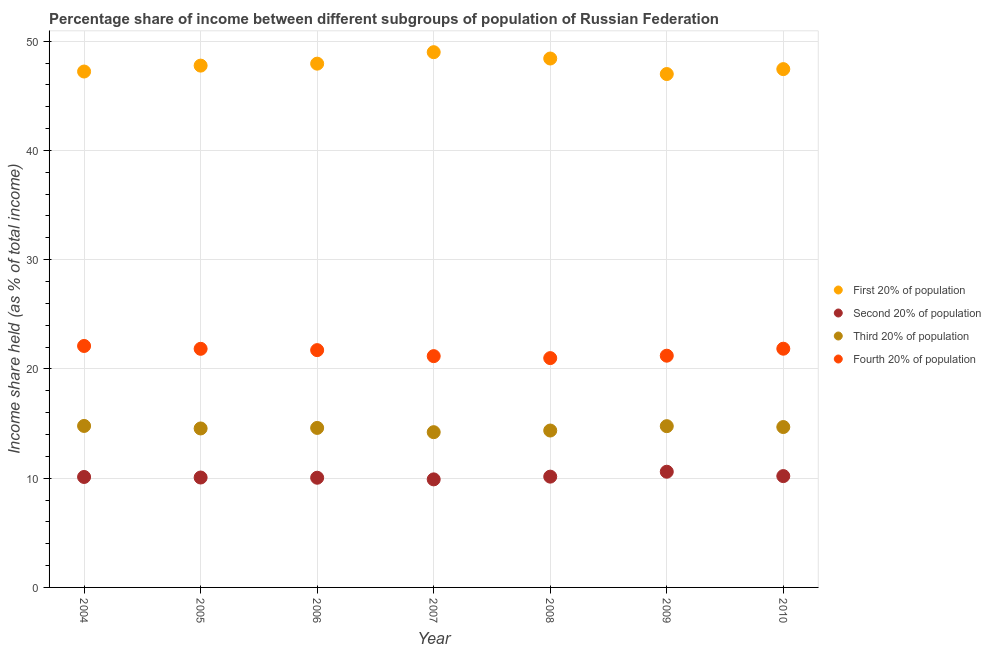How many different coloured dotlines are there?
Offer a terse response. 4. Is the number of dotlines equal to the number of legend labels?
Give a very brief answer. Yes. What is the share of the income held by second 20% of the population in 2006?
Keep it short and to the point. 10.04. Across all years, what is the maximum share of the income held by fourth 20% of the population?
Your answer should be compact. 22.1. Across all years, what is the minimum share of the income held by third 20% of the population?
Your answer should be compact. 14.21. In which year was the share of the income held by first 20% of the population minimum?
Provide a short and direct response. 2009. What is the total share of the income held by second 20% of the population in the graph?
Make the answer very short. 71.02. What is the difference between the share of the income held by first 20% of the population in 2005 and that in 2010?
Your answer should be very brief. 0.32. What is the difference between the share of the income held by fourth 20% of the population in 2006 and the share of the income held by second 20% of the population in 2009?
Provide a succinct answer. 11.13. What is the average share of the income held by third 20% of the population per year?
Give a very brief answer. 14.56. In the year 2006, what is the difference between the share of the income held by first 20% of the population and share of the income held by third 20% of the population?
Make the answer very short. 33.34. In how many years, is the share of the income held by second 20% of the population greater than 6 %?
Provide a succinct answer. 7. What is the ratio of the share of the income held by first 20% of the population in 2005 to that in 2010?
Provide a succinct answer. 1.01. What is the difference between the highest and the second highest share of the income held by third 20% of the population?
Provide a succinct answer. 0.02. What is the difference between the highest and the lowest share of the income held by fourth 20% of the population?
Keep it short and to the point. 1.11. Is the sum of the share of the income held by third 20% of the population in 2005 and 2009 greater than the maximum share of the income held by first 20% of the population across all years?
Offer a terse response. No. Is it the case that in every year, the sum of the share of the income held by second 20% of the population and share of the income held by first 20% of the population is greater than the sum of share of the income held by third 20% of the population and share of the income held by fourth 20% of the population?
Your answer should be compact. Yes. Does the share of the income held by second 20% of the population monotonically increase over the years?
Provide a short and direct response. No. Is the share of the income held by first 20% of the population strictly greater than the share of the income held by fourth 20% of the population over the years?
Your response must be concise. Yes. Is the share of the income held by third 20% of the population strictly less than the share of the income held by fourth 20% of the population over the years?
Offer a terse response. Yes. How many years are there in the graph?
Offer a very short reply. 7. Are the values on the major ticks of Y-axis written in scientific E-notation?
Make the answer very short. No. Does the graph contain grids?
Make the answer very short. Yes. How many legend labels are there?
Your answer should be very brief. 4. What is the title of the graph?
Your answer should be compact. Percentage share of income between different subgroups of population of Russian Federation. What is the label or title of the X-axis?
Ensure brevity in your answer.  Year. What is the label or title of the Y-axis?
Make the answer very short. Income share held (as % of total income). What is the Income share held (as % of total income) of First 20% of population in 2004?
Give a very brief answer. 47.22. What is the Income share held (as % of total income) in Second 20% of population in 2004?
Provide a succinct answer. 10.11. What is the Income share held (as % of total income) of Third 20% of population in 2004?
Keep it short and to the point. 14.78. What is the Income share held (as % of total income) in Fourth 20% of population in 2004?
Your response must be concise. 22.1. What is the Income share held (as % of total income) in First 20% of population in 2005?
Your answer should be very brief. 47.76. What is the Income share held (as % of total income) of Second 20% of population in 2005?
Offer a terse response. 10.06. What is the Income share held (as % of total income) in Third 20% of population in 2005?
Provide a succinct answer. 14.55. What is the Income share held (as % of total income) of Fourth 20% of population in 2005?
Make the answer very short. 21.84. What is the Income share held (as % of total income) in First 20% of population in 2006?
Provide a short and direct response. 47.94. What is the Income share held (as % of total income) of Second 20% of population in 2006?
Give a very brief answer. 10.04. What is the Income share held (as % of total income) in Fourth 20% of population in 2006?
Provide a short and direct response. 21.72. What is the Income share held (as % of total income) of First 20% of population in 2007?
Provide a succinct answer. 48.99. What is the Income share held (as % of total income) of Second 20% of population in 2007?
Offer a terse response. 9.89. What is the Income share held (as % of total income) in Third 20% of population in 2007?
Give a very brief answer. 14.21. What is the Income share held (as % of total income) in Fourth 20% of population in 2007?
Offer a terse response. 21.17. What is the Income share held (as % of total income) in First 20% of population in 2008?
Give a very brief answer. 48.41. What is the Income share held (as % of total income) of Second 20% of population in 2008?
Make the answer very short. 10.14. What is the Income share held (as % of total income) in Third 20% of population in 2008?
Ensure brevity in your answer.  14.36. What is the Income share held (as % of total income) in Fourth 20% of population in 2008?
Your answer should be very brief. 20.99. What is the Income share held (as % of total income) of First 20% of population in 2009?
Ensure brevity in your answer.  46.99. What is the Income share held (as % of total income) of Second 20% of population in 2009?
Make the answer very short. 10.59. What is the Income share held (as % of total income) in Third 20% of population in 2009?
Your response must be concise. 14.76. What is the Income share held (as % of total income) of Fourth 20% of population in 2009?
Your answer should be compact. 21.21. What is the Income share held (as % of total income) in First 20% of population in 2010?
Ensure brevity in your answer.  47.44. What is the Income share held (as % of total income) of Second 20% of population in 2010?
Your answer should be very brief. 10.19. What is the Income share held (as % of total income) of Third 20% of population in 2010?
Make the answer very short. 14.68. What is the Income share held (as % of total income) of Fourth 20% of population in 2010?
Give a very brief answer. 21.85. Across all years, what is the maximum Income share held (as % of total income) of First 20% of population?
Ensure brevity in your answer.  48.99. Across all years, what is the maximum Income share held (as % of total income) in Second 20% of population?
Make the answer very short. 10.59. Across all years, what is the maximum Income share held (as % of total income) of Third 20% of population?
Your answer should be compact. 14.78. Across all years, what is the maximum Income share held (as % of total income) of Fourth 20% of population?
Provide a short and direct response. 22.1. Across all years, what is the minimum Income share held (as % of total income) in First 20% of population?
Make the answer very short. 46.99. Across all years, what is the minimum Income share held (as % of total income) of Second 20% of population?
Your response must be concise. 9.89. Across all years, what is the minimum Income share held (as % of total income) in Third 20% of population?
Ensure brevity in your answer.  14.21. Across all years, what is the minimum Income share held (as % of total income) of Fourth 20% of population?
Keep it short and to the point. 20.99. What is the total Income share held (as % of total income) in First 20% of population in the graph?
Your answer should be very brief. 334.75. What is the total Income share held (as % of total income) in Second 20% of population in the graph?
Make the answer very short. 71.02. What is the total Income share held (as % of total income) of Third 20% of population in the graph?
Provide a short and direct response. 101.94. What is the total Income share held (as % of total income) of Fourth 20% of population in the graph?
Ensure brevity in your answer.  150.88. What is the difference between the Income share held (as % of total income) of First 20% of population in 2004 and that in 2005?
Your answer should be very brief. -0.54. What is the difference between the Income share held (as % of total income) of Third 20% of population in 2004 and that in 2005?
Offer a very short reply. 0.23. What is the difference between the Income share held (as % of total income) in Fourth 20% of population in 2004 and that in 2005?
Your answer should be compact. 0.26. What is the difference between the Income share held (as % of total income) of First 20% of population in 2004 and that in 2006?
Your answer should be compact. -0.72. What is the difference between the Income share held (as % of total income) in Second 20% of population in 2004 and that in 2006?
Your answer should be compact. 0.07. What is the difference between the Income share held (as % of total income) of Third 20% of population in 2004 and that in 2006?
Make the answer very short. 0.18. What is the difference between the Income share held (as % of total income) in Fourth 20% of population in 2004 and that in 2006?
Provide a succinct answer. 0.38. What is the difference between the Income share held (as % of total income) in First 20% of population in 2004 and that in 2007?
Offer a terse response. -1.77. What is the difference between the Income share held (as % of total income) in Second 20% of population in 2004 and that in 2007?
Offer a very short reply. 0.22. What is the difference between the Income share held (as % of total income) of Third 20% of population in 2004 and that in 2007?
Your answer should be very brief. 0.57. What is the difference between the Income share held (as % of total income) of Fourth 20% of population in 2004 and that in 2007?
Make the answer very short. 0.93. What is the difference between the Income share held (as % of total income) in First 20% of population in 2004 and that in 2008?
Provide a short and direct response. -1.19. What is the difference between the Income share held (as % of total income) in Second 20% of population in 2004 and that in 2008?
Provide a short and direct response. -0.03. What is the difference between the Income share held (as % of total income) in Third 20% of population in 2004 and that in 2008?
Provide a succinct answer. 0.42. What is the difference between the Income share held (as % of total income) in Fourth 20% of population in 2004 and that in 2008?
Make the answer very short. 1.11. What is the difference between the Income share held (as % of total income) in First 20% of population in 2004 and that in 2009?
Your answer should be very brief. 0.23. What is the difference between the Income share held (as % of total income) of Second 20% of population in 2004 and that in 2009?
Your answer should be compact. -0.48. What is the difference between the Income share held (as % of total income) of Third 20% of population in 2004 and that in 2009?
Keep it short and to the point. 0.02. What is the difference between the Income share held (as % of total income) of Fourth 20% of population in 2004 and that in 2009?
Your response must be concise. 0.89. What is the difference between the Income share held (as % of total income) of First 20% of population in 2004 and that in 2010?
Provide a succinct answer. -0.22. What is the difference between the Income share held (as % of total income) in Second 20% of population in 2004 and that in 2010?
Your answer should be very brief. -0.08. What is the difference between the Income share held (as % of total income) in Fourth 20% of population in 2004 and that in 2010?
Keep it short and to the point. 0.25. What is the difference between the Income share held (as % of total income) of First 20% of population in 2005 and that in 2006?
Provide a short and direct response. -0.18. What is the difference between the Income share held (as % of total income) of Second 20% of population in 2005 and that in 2006?
Your response must be concise. 0.02. What is the difference between the Income share held (as % of total income) of Fourth 20% of population in 2005 and that in 2006?
Your response must be concise. 0.12. What is the difference between the Income share held (as % of total income) of First 20% of population in 2005 and that in 2007?
Your answer should be very brief. -1.23. What is the difference between the Income share held (as % of total income) of Second 20% of population in 2005 and that in 2007?
Provide a short and direct response. 0.17. What is the difference between the Income share held (as % of total income) of Third 20% of population in 2005 and that in 2007?
Offer a very short reply. 0.34. What is the difference between the Income share held (as % of total income) of Fourth 20% of population in 2005 and that in 2007?
Your answer should be compact. 0.67. What is the difference between the Income share held (as % of total income) of First 20% of population in 2005 and that in 2008?
Offer a very short reply. -0.65. What is the difference between the Income share held (as % of total income) in Second 20% of population in 2005 and that in 2008?
Provide a succinct answer. -0.08. What is the difference between the Income share held (as % of total income) of Third 20% of population in 2005 and that in 2008?
Offer a very short reply. 0.19. What is the difference between the Income share held (as % of total income) of First 20% of population in 2005 and that in 2009?
Provide a short and direct response. 0.77. What is the difference between the Income share held (as % of total income) in Second 20% of population in 2005 and that in 2009?
Your answer should be compact. -0.53. What is the difference between the Income share held (as % of total income) of Third 20% of population in 2005 and that in 2009?
Keep it short and to the point. -0.21. What is the difference between the Income share held (as % of total income) of Fourth 20% of population in 2005 and that in 2009?
Keep it short and to the point. 0.63. What is the difference between the Income share held (as % of total income) of First 20% of population in 2005 and that in 2010?
Offer a terse response. 0.32. What is the difference between the Income share held (as % of total income) of Second 20% of population in 2005 and that in 2010?
Your answer should be very brief. -0.13. What is the difference between the Income share held (as % of total income) in Third 20% of population in 2005 and that in 2010?
Your answer should be compact. -0.13. What is the difference between the Income share held (as % of total income) of Fourth 20% of population in 2005 and that in 2010?
Keep it short and to the point. -0.01. What is the difference between the Income share held (as % of total income) in First 20% of population in 2006 and that in 2007?
Offer a very short reply. -1.05. What is the difference between the Income share held (as % of total income) of Third 20% of population in 2006 and that in 2007?
Make the answer very short. 0.39. What is the difference between the Income share held (as % of total income) in Fourth 20% of population in 2006 and that in 2007?
Provide a succinct answer. 0.55. What is the difference between the Income share held (as % of total income) of First 20% of population in 2006 and that in 2008?
Offer a very short reply. -0.47. What is the difference between the Income share held (as % of total income) in Second 20% of population in 2006 and that in 2008?
Your answer should be compact. -0.1. What is the difference between the Income share held (as % of total income) of Third 20% of population in 2006 and that in 2008?
Your answer should be very brief. 0.24. What is the difference between the Income share held (as % of total income) of Fourth 20% of population in 2006 and that in 2008?
Ensure brevity in your answer.  0.73. What is the difference between the Income share held (as % of total income) in Second 20% of population in 2006 and that in 2009?
Your answer should be compact. -0.55. What is the difference between the Income share held (as % of total income) in Third 20% of population in 2006 and that in 2009?
Keep it short and to the point. -0.16. What is the difference between the Income share held (as % of total income) in Fourth 20% of population in 2006 and that in 2009?
Provide a short and direct response. 0.51. What is the difference between the Income share held (as % of total income) of First 20% of population in 2006 and that in 2010?
Your answer should be very brief. 0.5. What is the difference between the Income share held (as % of total income) of Second 20% of population in 2006 and that in 2010?
Give a very brief answer. -0.15. What is the difference between the Income share held (as % of total income) in Third 20% of population in 2006 and that in 2010?
Offer a terse response. -0.08. What is the difference between the Income share held (as % of total income) of Fourth 20% of population in 2006 and that in 2010?
Provide a short and direct response. -0.13. What is the difference between the Income share held (as % of total income) in First 20% of population in 2007 and that in 2008?
Provide a short and direct response. 0.58. What is the difference between the Income share held (as % of total income) of Third 20% of population in 2007 and that in 2008?
Give a very brief answer. -0.15. What is the difference between the Income share held (as % of total income) of Fourth 20% of population in 2007 and that in 2008?
Give a very brief answer. 0.18. What is the difference between the Income share held (as % of total income) of First 20% of population in 2007 and that in 2009?
Your response must be concise. 2. What is the difference between the Income share held (as % of total income) in Third 20% of population in 2007 and that in 2009?
Give a very brief answer. -0.55. What is the difference between the Income share held (as % of total income) of Fourth 20% of population in 2007 and that in 2009?
Your answer should be very brief. -0.04. What is the difference between the Income share held (as % of total income) in First 20% of population in 2007 and that in 2010?
Your response must be concise. 1.55. What is the difference between the Income share held (as % of total income) in Third 20% of population in 2007 and that in 2010?
Your answer should be very brief. -0.47. What is the difference between the Income share held (as % of total income) in Fourth 20% of population in 2007 and that in 2010?
Ensure brevity in your answer.  -0.68. What is the difference between the Income share held (as % of total income) in First 20% of population in 2008 and that in 2009?
Your answer should be compact. 1.42. What is the difference between the Income share held (as % of total income) of Second 20% of population in 2008 and that in 2009?
Offer a terse response. -0.45. What is the difference between the Income share held (as % of total income) of Third 20% of population in 2008 and that in 2009?
Offer a terse response. -0.4. What is the difference between the Income share held (as % of total income) in Fourth 20% of population in 2008 and that in 2009?
Your answer should be compact. -0.22. What is the difference between the Income share held (as % of total income) of First 20% of population in 2008 and that in 2010?
Your answer should be very brief. 0.97. What is the difference between the Income share held (as % of total income) in Second 20% of population in 2008 and that in 2010?
Offer a very short reply. -0.05. What is the difference between the Income share held (as % of total income) in Third 20% of population in 2008 and that in 2010?
Offer a very short reply. -0.32. What is the difference between the Income share held (as % of total income) in Fourth 20% of population in 2008 and that in 2010?
Make the answer very short. -0.86. What is the difference between the Income share held (as % of total income) of First 20% of population in 2009 and that in 2010?
Provide a succinct answer. -0.45. What is the difference between the Income share held (as % of total income) of Third 20% of population in 2009 and that in 2010?
Make the answer very short. 0.08. What is the difference between the Income share held (as % of total income) of Fourth 20% of population in 2009 and that in 2010?
Provide a succinct answer. -0.64. What is the difference between the Income share held (as % of total income) in First 20% of population in 2004 and the Income share held (as % of total income) in Second 20% of population in 2005?
Offer a very short reply. 37.16. What is the difference between the Income share held (as % of total income) in First 20% of population in 2004 and the Income share held (as % of total income) in Third 20% of population in 2005?
Your answer should be compact. 32.67. What is the difference between the Income share held (as % of total income) of First 20% of population in 2004 and the Income share held (as % of total income) of Fourth 20% of population in 2005?
Give a very brief answer. 25.38. What is the difference between the Income share held (as % of total income) in Second 20% of population in 2004 and the Income share held (as % of total income) in Third 20% of population in 2005?
Give a very brief answer. -4.44. What is the difference between the Income share held (as % of total income) of Second 20% of population in 2004 and the Income share held (as % of total income) of Fourth 20% of population in 2005?
Offer a terse response. -11.73. What is the difference between the Income share held (as % of total income) in Third 20% of population in 2004 and the Income share held (as % of total income) in Fourth 20% of population in 2005?
Ensure brevity in your answer.  -7.06. What is the difference between the Income share held (as % of total income) in First 20% of population in 2004 and the Income share held (as % of total income) in Second 20% of population in 2006?
Make the answer very short. 37.18. What is the difference between the Income share held (as % of total income) of First 20% of population in 2004 and the Income share held (as % of total income) of Third 20% of population in 2006?
Provide a succinct answer. 32.62. What is the difference between the Income share held (as % of total income) of Second 20% of population in 2004 and the Income share held (as % of total income) of Third 20% of population in 2006?
Offer a very short reply. -4.49. What is the difference between the Income share held (as % of total income) of Second 20% of population in 2004 and the Income share held (as % of total income) of Fourth 20% of population in 2006?
Your answer should be compact. -11.61. What is the difference between the Income share held (as % of total income) in Third 20% of population in 2004 and the Income share held (as % of total income) in Fourth 20% of population in 2006?
Your answer should be very brief. -6.94. What is the difference between the Income share held (as % of total income) in First 20% of population in 2004 and the Income share held (as % of total income) in Second 20% of population in 2007?
Offer a very short reply. 37.33. What is the difference between the Income share held (as % of total income) of First 20% of population in 2004 and the Income share held (as % of total income) of Third 20% of population in 2007?
Your answer should be very brief. 33.01. What is the difference between the Income share held (as % of total income) in First 20% of population in 2004 and the Income share held (as % of total income) in Fourth 20% of population in 2007?
Provide a succinct answer. 26.05. What is the difference between the Income share held (as % of total income) in Second 20% of population in 2004 and the Income share held (as % of total income) in Fourth 20% of population in 2007?
Keep it short and to the point. -11.06. What is the difference between the Income share held (as % of total income) of Third 20% of population in 2004 and the Income share held (as % of total income) of Fourth 20% of population in 2007?
Keep it short and to the point. -6.39. What is the difference between the Income share held (as % of total income) in First 20% of population in 2004 and the Income share held (as % of total income) in Second 20% of population in 2008?
Ensure brevity in your answer.  37.08. What is the difference between the Income share held (as % of total income) of First 20% of population in 2004 and the Income share held (as % of total income) of Third 20% of population in 2008?
Your answer should be very brief. 32.86. What is the difference between the Income share held (as % of total income) of First 20% of population in 2004 and the Income share held (as % of total income) of Fourth 20% of population in 2008?
Make the answer very short. 26.23. What is the difference between the Income share held (as % of total income) in Second 20% of population in 2004 and the Income share held (as % of total income) in Third 20% of population in 2008?
Make the answer very short. -4.25. What is the difference between the Income share held (as % of total income) of Second 20% of population in 2004 and the Income share held (as % of total income) of Fourth 20% of population in 2008?
Provide a short and direct response. -10.88. What is the difference between the Income share held (as % of total income) of Third 20% of population in 2004 and the Income share held (as % of total income) of Fourth 20% of population in 2008?
Your answer should be compact. -6.21. What is the difference between the Income share held (as % of total income) in First 20% of population in 2004 and the Income share held (as % of total income) in Second 20% of population in 2009?
Ensure brevity in your answer.  36.63. What is the difference between the Income share held (as % of total income) of First 20% of population in 2004 and the Income share held (as % of total income) of Third 20% of population in 2009?
Your answer should be very brief. 32.46. What is the difference between the Income share held (as % of total income) of First 20% of population in 2004 and the Income share held (as % of total income) of Fourth 20% of population in 2009?
Provide a succinct answer. 26.01. What is the difference between the Income share held (as % of total income) in Second 20% of population in 2004 and the Income share held (as % of total income) in Third 20% of population in 2009?
Keep it short and to the point. -4.65. What is the difference between the Income share held (as % of total income) in Third 20% of population in 2004 and the Income share held (as % of total income) in Fourth 20% of population in 2009?
Keep it short and to the point. -6.43. What is the difference between the Income share held (as % of total income) of First 20% of population in 2004 and the Income share held (as % of total income) of Second 20% of population in 2010?
Make the answer very short. 37.03. What is the difference between the Income share held (as % of total income) in First 20% of population in 2004 and the Income share held (as % of total income) in Third 20% of population in 2010?
Offer a terse response. 32.54. What is the difference between the Income share held (as % of total income) of First 20% of population in 2004 and the Income share held (as % of total income) of Fourth 20% of population in 2010?
Offer a very short reply. 25.37. What is the difference between the Income share held (as % of total income) of Second 20% of population in 2004 and the Income share held (as % of total income) of Third 20% of population in 2010?
Keep it short and to the point. -4.57. What is the difference between the Income share held (as % of total income) in Second 20% of population in 2004 and the Income share held (as % of total income) in Fourth 20% of population in 2010?
Ensure brevity in your answer.  -11.74. What is the difference between the Income share held (as % of total income) of Third 20% of population in 2004 and the Income share held (as % of total income) of Fourth 20% of population in 2010?
Ensure brevity in your answer.  -7.07. What is the difference between the Income share held (as % of total income) in First 20% of population in 2005 and the Income share held (as % of total income) in Second 20% of population in 2006?
Provide a succinct answer. 37.72. What is the difference between the Income share held (as % of total income) of First 20% of population in 2005 and the Income share held (as % of total income) of Third 20% of population in 2006?
Offer a terse response. 33.16. What is the difference between the Income share held (as % of total income) in First 20% of population in 2005 and the Income share held (as % of total income) in Fourth 20% of population in 2006?
Provide a short and direct response. 26.04. What is the difference between the Income share held (as % of total income) in Second 20% of population in 2005 and the Income share held (as % of total income) in Third 20% of population in 2006?
Ensure brevity in your answer.  -4.54. What is the difference between the Income share held (as % of total income) of Second 20% of population in 2005 and the Income share held (as % of total income) of Fourth 20% of population in 2006?
Your answer should be compact. -11.66. What is the difference between the Income share held (as % of total income) in Third 20% of population in 2005 and the Income share held (as % of total income) in Fourth 20% of population in 2006?
Offer a very short reply. -7.17. What is the difference between the Income share held (as % of total income) of First 20% of population in 2005 and the Income share held (as % of total income) of Second 20% of population in 2007?
Offer a terse response. 37.87. What is the difference between the Income share held (as % of total income) of First 20% of population in 2005 and the Income share held (as % of total income) of Third 20% of population in 2007?
Your answer should be very brief. 33.55. What is the difference between the Income share held (as % of total income) in First 20% of population in 2005 and the Income share held (as % of total income) in Fourth 20% of population in 2007?
Your response must be concise. 26.59. What is the difference between the Income share held (as % of total income) in Second 20% of population in 2005 and the Income share held (as % of total income) in Third 20% of population in 2007?
Give a very brief answer. -4.15. What is the difference between the Income share held (as % of total income) in Second 20% of population in 2005 and the Income share held (as % of total income) in Fourth 20% of population in 2007?
Provide a succinct answer. -11.11. What is the difference between the Income share held (as % of total income) of Third 20% of population in 2005 and the Income share held (as % of total income) of Fourth 20% of population in 2007?
Ensure brevity in your answer.  -6.62. What is the difference between the Income share held (as % of total income) of First 20% of population in 2005 and the Income share held (as % of total income) of Second 20% of population in 2008?
Your response must be concise. 37.62. What is the difference between the Income share held (as % of total income) of First 20% of population in 2005 and the Income share held (as % of total income) of Third 20% of population in 2008?
Offer a terse response. 33.4. What is the difference between the Income share held (as % of total income) in First 20% of population in 2005 and the Income share held (as % of total income) in Fourth 20% of population in 2008?
Give a very brief answer. 26.77. What is the difference between the Income share held (as % of total income) of Second 20% of population in 2005 and the Income share held (as % of total income) of Third 20% of population in 2008?
Your response must be concise. -4.3. What is the difference between the Income share held (as % of total income) of Second 20% of population in 2005 and the Income share held (as % of total income) of Fourth 20% of population in 2008?
Your answer should be compact. -10.93. What is the difference between the Income share held (as % of total income) in Third 20% of population in 2005 and the Income share held (as % of total income) in Fourth 20% of population in 2008?
Your answer should be compact. -6.44. What is the difference between the Income share held (as % of total income) in First 20% of population in 2005 and the Income share held (as % of total income) in Second 20% of population in 2009?
Offer a very short reply. 37.17. What is the difference between the Income share held (as % of total income) of First 20% of population in 2005 and the Income share held (as % of total income) of Fourth 20% of population in 2009?
Provide a succinct answer. 26.55. What is the difference between the Income share held (as % of total income) in Second 20% of population in 2005 and the Income share held (as % of total income) in Third 20% of population in 2009?
Provide a succinct answer. -4.7. What is the difference between the Income share held (as % of total income) of Second 20% of population in 2005 and the Income share held (as % of total income) of Fourth 20% of population in 2009?
Make the answer very short. -11.15. What is the difference between the Income share held (as % of total income) in Third 20% of population in 2005 and the Income share held (as % of total income) in Fourth 20% of population in 2009?
Offer a very short reply. -6.66. What is the difference between the Income share held (as % of total income) of First 20% of population in 2005 and the Income share held (as % of total income) of Second 20% of population in 2010?
Offer a terse response. 37.57. What is the difference between the Income share held (as % of total income) of First 20% of population in 2005 and the Income share held (as % of total income) of Third 20% of population in 2010?
Ensure brevity in your answer.  33.08. What is the difference between the Income share held (as % of total income) of First 20% of population in 2005 and the Income share held (as % of total income) of Fourth 20% of population in 2010?
Provide a short and direct response. 25.91. What is the difference between the Income share held (as % of total income) of Second 20% of population in 2005 and the Income share held (as % of total income) of Third 20% of population in 2010?
Give a very brief answer. -4.62. What is the difference between the Income share held (as % of total income) of Second 20% of population in 2005 and the Income share held (as % of total income) of Fourth 20% of population in 2010?
Your answer should be very brief. -11.79. What is the difference between the Income share held (as % of total income) in First 20% of population in 2006 and the Income share held (as % of total income) in Second 20% of population in 2007?
Your answer should be compact. 38.05. What is the difference between the Income share held (as % of total income) in First 20% of population in 2006 and the Income share held (as % of total income) in Third 20% of population in 2007?
Provide a succinct answer. 33.73. What is the difference between the Income share held (as % of total income) in First 20% of population in 2006 and the Income share held (as % of total income) in Fourth 20% of population in 2007?
Ensure brevity in your answer.  26.77. What is the difference between the Income share held (as % of total income) in Second 20% of population in 2006 and the Income share held (as % of total income) in Third 20% of population in 2007?
Give a very brief answer. -4.17. What is the difference between the Income share held (as % of total income) of Second 20% of population in 2006 and the Income share held (as % of total income) of Fourth 20% of population in 2007?
Ensure brevity in your answer.  -11.13. What is the difference between the Income share held (as % of total income) in Third 20% of population in 2006 and the Income share held (as % of total income) in Fourth 20% of population in 2007?
Provide a short and direct response. -6.57. What is the difference between the Income share held (as % of total income) in First 20% of population in 2006 and the Income share held (as % of total income) in Second 20% of population in 2008?
Give a very brief answer. 37.8. What is the difference between the Income share held (as % of total income) in First 20% of population in 2006 and the Income share held (as % of total income) in Third 20% of population in 2008?
Your answer should be compact. 33.58. What is the difference between the Income share held (as % of total income) of First 20% of population in 2006 and the Income share held (as % of total income) of Fourth 20% of population in 2008?
Offer a terse response. 26.95. What is the difference between the Income share held (as % of total income) of Second 20% of population in 2006 and the Income share held (as % of total income) of Third 20% of population in 2008?
Your response must be concise. -4.32. What is the difference between the Income share held (as % of total income) in Second 20% of population in 2006 and the Income share held (as % of total income) in Fourth 20% of population in 2008?
Provide a succinct answer. -10.95. What is the difference between the Income share held (as % of total income) in Third 20% of population in 2006 and the Income share held (as % of total income) in Fourth 20% of population in 2008?
Your answer should be very brief. -6.39. What is the difference between the Income share held (as % of total income) in First 20% of population in 2006 and the Income share held (as % of total income) in Second 20% of population in 2009?
Provide a succinct answer. 37.35. What is the difference between the Income share held (as % of total income) of First 20% of population in 2006 and the Income share held (as % of total income) of Third 20% of population in 2009?
Your answer should be compact. 33.18. What is the difference between the Income share held (as % of total income) of First 20% of population in 2006 and the Income share held (as % of total income) of Fourth 20% of population in 2009?
Provide a succinct answer. 26.73. What is the difference between the Income share held (as % of total income) of Second 20% of population in 2006 and the Income share held (as % of total income) of Third 20% of population in 2009?
Make the answer very short. -4.72. What is the difference between the Income share held (as % of total income) in Second 20% of population in 2006 and the Income share held (as % of total income) in Fourth 20% of population in 2009?
Your answer should be compact. -11.17. What is the difference between the Income share held (as % of total income) in Third 20% of population in 2006 and the Income share held (as % of total income) in Fourth 20% of population in 2009?
Ensure brevity in your answer.  -6.61. What is the difference between the Income share held (as % of total income) in First 20% of population in 2006 and the Income share held (as % of total income) in Second 20% of population in 2010?
Give a very brief answer. 37.75. What is the difference between the Income share held (as % of total income) of First 20% of population in 2006 and the Income share held (as % of total income) of Third 20% of population in 2010?
Give a very brief answer. 33.26. What is the difference between the Income share held (as % of total income) of First 20% of population in 2006 and the Income share held (as % of total income) of Fourth 20% of population in 2010?
Offer a terse response. 26.09. What is the difference between the Income share held (as % of total income) of Second 20% of population in 2006 and the Income share held (as % of total income) of Third 20% of population in 2010?
Make the answer very short. -4.64. What is the difference between the Income share held (as % of total income) in Second 20% of population in 2006 and the Income share held (as % of total income) in Fourth 20% of population in 2010?
Make the answer very short. -11.81. What is the difference between the Income share held (as % of total income) of Third 20% of population in 2006 and the Income share held (as % of total income) of Fourth 20% of population in 2010?
Make the answer very short. -7.25. What is the difference between the Income share held (as % of total income) of First 20% of population in 2007 and the Income share held (as % of total income) of Second 20% of population in 2008?
Offer a very short reply. 38.85. What is the difference between the Income share held (as % of total income) of First 20% of population in 2007 and the Income share held (as % of total income) of Third 20% of population in 2008?
Offer a terse response. 34.63. What is the difference between the Income share held (as % of total income) in Second 20% of population in 2007 and the Income share held (as % of total income) in Third 20% of population in 2008?
Ensure brevity in your answer.  -4.47. What is the difference between the Income share held (as % of total income) of Third 20% of population in 2007 and the Income share held (as % of total income) of Fourth 20% of population in 2008?
Provide a succinct answer. -6.78. What is the difference between the Income share held (as % of total income) in First 20% of population in 2007 and the Income share held (as % of total income) in Second 20% of population in 2009?
Keep it short and to the point. 38.4. What is the difference between the Income share held (as % of total income) in First 20% of population in 2007 and the Income share held (as % of total income) in Third 20% of population in 2009?
Offer a very short reply. 34.23. What is the difference between the Income share held (as % of total income) in First 20% of population in 2007 and the Income share held (as % of total income) in Fourth 20% of population in 2009?
Keep it short and to the point. 27.78. What is the difference between the Income share held (as % of total income) in Second 20% of population in 2007 and the Income share held (as % of total income) in Third 20% of population in 2009?
Give a very brief answer. -4.87. What is the difference between the Income share held (as % of total income) in Second 20% of population in 2007 and the Income share held (as % of total income) in Fourth 20% of population in 2009?
Give a very brief answer. -11.32. What is the difference between the Income share held (as % of total income) of First 20% of population in 2007 and the Income share held (as % of total income) of Second 20% of population in 2010?
Give a very brief answer. 38.8. What is the difference between the Income share held (as % of total income) in First 20% of population in 2007 and the Income share held (as % of total income) in Third 20% of population in 2010?
Your response must be concise. 34.31. What is the difference between the Income share held (as % of total income) of First 20% of population in 2007 and the Income share held (as % of total income) of Fourth 20% of population in 2010?
Offer a terse response. 27.14. What is the difference between the Income share held (as % of total income) in Second 20% of population in 2007 and the Income share held (as % of total income) in Third 20% of population in 2010?
Give a very brief answer. -4.79. What is the difference between the Income share held (as % of total income) in Second 20% of population in 2007 and the Income share held (as % of total income) in Fourth 20% of population in 2010?
Make the answer very short. -11.96. What is the difference between the Income share held (as % of total income) in Third 20% of population in 2007 and the Income share held (as % of total income) in Fourth 20% of population in 2010?
Make the answer very short. -7.64. What is the difference between the Income share held (as % of total income) of First 20% of population in 2008 and the Income share held (as % of total income) of Second 20% of population in 2009?
Your response must be concise. 37.82. What is the difference between the Income share held (as % of total income) in First 20% of population in 2008 and the Income share held (as % of total income) in Third 20% of population in 2009?
Your answer should be compact. 33.65. What is the difference between the Income share held (as % of total income) of First 20% of population in 2008 and the Income share held (as % of total income) of Fourth 20% of population in 2009?
Ensure brevity in your answer.  27.2. What is the difference between the Income share held (as % of total income) in Second 20% of population in 2008 and the Income share held (as % of total income) in Third 20% of population in 2009?
Your response must be concise. -4.62. What is the difference between the Income share held (as % of total income) in Second 20% of population in 2008 and the Income share held (as % of total income) in Fourth 20% of population in 2009?
Offer a very short reply. -11.07. What is the difference between the Income share held (as % of total income) in Third 20% of population in 2008 and the Income share held (as % of total income) in Fourth 20% of population in 2009?
Your answer should be very brief. -6.85. What is the difference between the Income share held (as % of total income) of First 20% of population in 2008 and the Income share held (as % of total income) of Second 20% of population in 2010?
Your response must be concise. 38.22. What is the difference between the Income share held (as % of total income) of First 20% of population in 2008 and the Income share held (as % of total income) of Third 20% of population in 2010?
Your response must be concise. 33.73. What is the difference between the Income share held (as % of total income) in First 20% of population in 2008 and the Income share held (as % of total income) in Fourth 20% of population in 2010?
Make the answer very short. 26.56. What is the difference between the Income share held (as % of total income) in Second 20% of population in 2008 and the Income share held (as % of total income) in Third 20% of population in 2010?
Provide a succinct answer. -4.54. What is the difference between the Income share held (as % of total income) in Second 20% of population in 2008 and the Income share held (as % of total income) in Fourth 20% of population in 2010?
Your answer should be compact. -11.71. What is the difference between the Income share held (as % of total income) in Third 20% of population in 2008 and the Income share held (as % of total income) in Fourth 20% of population in 2010?
Give a very brief answer. -7.49. What is the difference between the Income share held (as % of total income) in First 20% of population in 2009 and the Income share held (as % of total income) in Second 20% of population in 2010?
Keep it short and to the point. 36.8. What is the difference between the Income share held (as % of total income) in First 20% of population in 2009 and the Income share held (as % of total income) in Third 20% of population in 2010?
Your response must be concise. 32.31. What is the difference between the Income share held (as % of total income) in First 20% of population in 2009 and the Income share held (as % of total income) in Fourth 20% of population in 2010?
Offer a terse response. 25.14. What is the difference between the Income share held (as % of total income) of Second 20% of population in 2009 and the Income share held (as % of total income) of Third 20% of population in 2010?
Make the answer very short. -4.09. What is the difference between the Income share held (as % of total income) of Second 20% of population in 2009 and the Income share held (as % of total income) of Fourth 20% of population in 2010?
Your answer should be compact. -11.26. What is the difference between the Income share held (as % of total income) of Third 20% of population in 2009 and the Income share held (as % of total income) of Fourth 20% of population in 2010?
Offer a terse response. -7.09. What is the average Income share held (as % of total income) of First 20% of population per year?
Your response must be concise. 47.82. What is the average Income share held (as % of total income) in Second 20% of population per year?
Your answer should be very brief. 10.15. What is the average Income share held (as % of total income) in Third 20% of population per year?
Your answer should be very brief. 14.56. What is the average Income share held (as % of total income) in Fourth 20% of population per year?
Make the answer very short. 21.55. In the year 2004, what is the difference between the Income share held (as % of total income) in First 20% of population and Income share held (as % of total income) in Second 20% of population?
Provide a short and direct response. 37.11. In the year 2004, what is the difference between the Income share held (as % of total income) in First 20% of population and Income share held (as % of total income) in Third 20% of population?
Offer a very short reply. 32.44. In the year 2004, what is the difference between the Income share held (as % of total income) in First 20% of population and Income share held (as % of total income) in Fourth 20% of population?
Keep it short and to the point. 25.12. In the year 2004, what is the difference between the Income share held (as % of total income) of Second 20% of population and Income share held (as % of total income) of Third 20% of population?
Ensure brevity in your answer.  -4.67. In the year 2004, what is the difference between the Income share held (as % of total income) in Second 20% of population and Income share held (as % of total income) in Fourth 20% of population?
Your response must be concise. -11.99. In the year 2004, what is the difference between the Income share held (as % of total income) in Third 20% of population and Income share held (as % of total income) in Fourth 20% of population?
Give a very brief answer. -7.32. In the year 2005, what is the difference between the Income share held (as % of total income) in First 20% of population and Income share held (as % of total income) in Second 20% of population?
Provide a succinct answer. 37.7. In the year 2005, what is the difference between the Income share held (as % of total income) of First 20% of population and Income share held (as % of total income) of Third 20% of population?
Your response must be concise. 33.21. In the year 2005, what is the difference between the Income share held (as % of total income) of First 20% of population and Income share held (as % of total income) of Fourth 20% of population?
Offer a very short reply. 25.92. In the year 2005, what is the difference between the Income share held (as % of total income) of Second 20% of population and Income share held (as % of total income) of Third 20% of population?
Your response must be concise. -4.49. In the year 2005, what is the difference between the Income share held (as % of total income) in Second 20% of population and Income share held (as % of total income) in Fourth 20% of population?
Your answer should be very brief. -11.78. In the year 2005, what is the difference between the Income share held (as % of total income) in Third 20% of population and Income share held (as % of total income) in Fourth 20% of population?
Ensure brevity in your answer.  -7.29. In the year 2006, what is the difference between the Income share held (as % of total income) in First 20% of population and Income share held (as % of total income) in Second 20% of population?
Your response must be concise. 37.9. In the year 2006, what is the difference between the Income share held (as % of total income) in First 20% of population and Income share held (as % of total income) in Third 20% of population?
Make the answer very short. 33.34. In the year 2006, what is the difference between the Income share held (as % of total income) of First 20% of population and Income share held (as % of total income) of Fourth 20% of population?
Ensure brevity in your answer.  26.22. In the year 2006, what is the difference between the Income share held (as % of total income) in Second 20% of population and Income share held (as % of total income) in Third 20% of population?
Offer a terse response. -4.56. In the year 2006, what is the difference between the Income share held (as % of total income) of Second 20% of population and Income share held (as % of total income) of Fourth 20% of population?
Your response must be concise. -11.68. In the year 2006, what is the difference between the Income share held (as % of total income) of Third 20% of population and Income share held (as % of total income) of Fourth 20% of population?
Make the answer very short. -7.12. In the year 2007, what is the difference between the Income share held (as % of total income) of First 20% of population and Income share held (as % of total income) of Second 20% of population?
Your response must be concise. 39.1. In the year 2007, what is the difference between the Income share held (as % of total income) in First 20% of population and Income share held (as % of total income) in Third 20% of population?
Ensure brevity in your answer.  34.78. In the year 2007, what is the difference between the Income share held (as % of total income) of First 20% of population and Income share held (as % of total income) of Fourth 20% of population?
Your answer should be very brief. 27.82. In the year 2007, what is the difference between the Income share held (as % of total income) of Second 20% of population and Income share held (as % of total income) of Third 20% of population?
Provide a short and direct response. -4.32. In the year 2007, what is the difference between the Income share held (as % of total income) in Second 20% of population and Income share held (as % of total income) in Fourth 20% of population?
Offer a terse response. -11.28. In the year 2007, what is the difference between the Income share held (as % of total income) in Third 20% of population and Income share held (as % of total income) in Fourth 20% of population?
Keep it short and to the point. -6.96. In the year 2008, what is the difference between the Income share held (as % of total income) of First 20% of population and Income share held (as % of total income) of Second 20% of population?
Ensure brevity in your answer.  38.27. In the year 2008, what is the difference between the Income share held (as % of total income) of First 20% of population and Income share held (as % of total income) of Third 20% of population?
Your response must be concise. 34.05. In the year 2008, what is the difference between the Income share held (as % of total income) in First 20% of population and Income share held (as % of total income) in Fourth 20% of population?
Provide a succinct answer. 27.42. In the year 2008, what is the difference between the Income share held (as % of total income) in Second 20% of population and Income share held (as % of total income) in Third 20% of population?
Your answer should be very brief. -4.22. In the year 2008, what is the difference between the Income share held (as % of total income) in Second 20% of population and Income share held (as % of total income) in Fourth 20% of population?
Your response must be concise. -10.85. In the year 2008, what is the difference between the Income share held (as % of total income) of Third 20% of population and Income share held (as % of total income) of Fourth 20% of population?
Give a very brief answer. -6.63. In the year 2009, what is the difference between the Income share held (as % of total income) in First 20% of population and Income share held (as % of total income) in Second 20% of population?
Your answer should be very brief. 36.4. In the year 2009, what is the difference between the Income share held (as % of total income) of First 20% of population and Income share held (as % of total income) of Third 20% of population?
Your answer should be very brief. 32.23. In the year 2009, what is the difference between the Income share held (as % of total income) of First 20% of population and Income share held (as % of total income) of Fourth 20% of population?
Ensure brevity in your answer.  25.78. In the year 2009, what is the difference between the Income share held (as % of total income) of Second 20% of population and Income share held (as % of total income) of Third 20% of population?
Provide a succinct answer. -4.17. In the year 2009, what is the difference between the Income share held (as % of total income) in Second 20% of population and Income share held (as % of total income) in Fourth 20% of population?
Provide a succinct answer. -10.62. In the year 2009, what is the difference between the Income share held (as % of total income) in Third 20% of population and Income share held (as % of total income) in Fourth 20% of population?
Provide a short and direct response. -6.45. In the year 2010, what is the difference between the Income share held (as % of total income) in First 20% of population and Income share held (as % of total income) in Second 20% of population?
Your response must be concise. 37.25. In the year 2010, what is the difference between the Income share held (as % of total income) of First 20% of population and Income share held (as % of total income) of Third 20% of population?
Ensure brevity in your answer.  32.76. In the year 2010, what is the difference between the Income share held (as % of total income) in First 20% of population and Income share held (as % of total income) in Fourth 20% of population?
Ensure brevity in your answer.  25.59. In the year 2010, what is the difference between the Income share held (as % of total income) in Second 20% of population and Income share held (as % of total income) in Third 20% of population?
Your answer should be very brief. -4.49. In the year 2010, what is the difference between the Income share held (as % of total income) in Second 20% of population and Income share held (as % of total income) in Fourth 20% of population?
Make the answer very short. -11.66. In the year 2010, what is the difference between the Income share held (as % of total income) in Third 20% of population and Income share held (as % of total income) in Fourth 20% of population?
Offer a terse response. -7.17. What is the ratio of the Income share held (as % of total income) in First 20% of population in 2004 to that in 2005?
Give a very brief answer. 0.99. What is the ratio of the Income share held (as % of total income) in Third 20% of population in 2004 to that in 2005?
Your answer should be compact. 1.02. What is the ratio of the Income share held (as % of total income) of Fourth 20% of population in 2004 to that in 2005?
Your answer should be very brief. 1.01. What is the ratio of the Income share held (as % of total income) of First 20% of population in 2004 to that in 2006?
Your answer should be compact. 0.98. What is the ratio of the Income share held (as % of total income) of Third 20% of population in 2004 to that in 2006?
Offer a terse response. 1.01. What is the ratio of the Income share held (as % of total income) of Fourth 20% of population in 2004 to that in 2006?
Your answer should be compact. 1.02. What is the ratio of the Income share held (as % of total income) in First 20% of population in 2004 to that in 2007?
Give a very brief answer. 0.96. What is the ratio of the Income share held (as % of total income) of Second 20% of population in 2004 to that in 2007?
Your response must be concise. 1.02. What is the ratio of the Income share held (as % of total income) in Third 20% of population in 2004 to that in 2007?
Your answer should be very brief. 1.04. What is the ratio of the Income share held (as % of total income) in Fourth 20% of population in 2004 to that in 2007?
Provide a short and direct response. 1.04. What is the ratio of the Income share held (as % of total income) in First 20% of population in 2004 to that in 2008?
Offer a very short reply. 0.98. What is the ratio of the Income share held (as % of total income) of Third 20% of population in 2004 to that in 2008?
Provide a short and direct response. 1.03. What is the ratio of the Income share held (as % of total income) in Fourth 20% of population in 2004 to that in 2008?
Provide a succinct answer. 1.05. What is the ratio of the Income share held (as % of total income) in First 20% of population in 2004 to that in 2009?
Make the answer very short. 1. What is the ratio of the Income share held (as % of total income) in Second 20% of population in 2004 to that in 2009?
Keep it short and to the point. 0.95. What is the ratio of the Income share held (as % of total income) in Third 20% of population in 2004 to that in 2009?
Provide a succinct answer. 1. What is the ratio of the Income share held (as % of total income) of Fourth 20% of population in 2004 to that in 2009?
Make the answer very short. 1.04. What is the ratio of the Income share held (as % of total income) in Second 20% of population in 2004 to that in 2010?
Keep it short and to the point. 0.99. What is the ratio of the Income share held (as % of total income) in Third 20% of population in 2004 to that in 2010?
Offer a terse response. 1.01. What is the ratio of the Income share held (as % of total income) in Fourth 20% of population in 2004 to that in 2010?
Provide a succinct answer. 1.01. What is the ratio of the Income share held (as % of total income) in First 20% of population in 2005 to that in 2006?
Give a very brief answer. 1. What is the ratio of the Income share held (as % of total income) in Third 20% of population in 2005 to that in 2006?
Offer a very short reply. 1. What is the ratio of the Income share held (as % of total income) of Fourth 20% of population in 2005 to that in 2006?
Keep it short and to the point. 1.01. What is the ratio of the Income share held (as % of total income) in First 20% of population in 2005 to that in 2007?
Your response must be concise. 0.97. What is the ratio of the Income share held (as % of total income) in Second 20% of population in 2005 to that in 2007?
Your answer should be compact. 1.02. What is the ratio of the Income share held (as % of total income) in Third 20% of population in 2005 to that in 2007?
Ensure brevity in your answer.  1.02. What is the ratio of the Income share held (as % of total income) of Fourth 20% of population in 2005 to that in 2007?
Give a very brief answer. 1.03. What is the ratio of the Income share held (as % of total income) of First 20% of population in 2005 to that in 2008?
Your response must be concise. 0.99. What is the ratio of the Income share held (as % of total income) of Third 20% of population in 2005 to that in 2008?
Keep it short and to the point. 1.01. What is the ratio of the Income share held (as % of total income) of Fourth 20% of population in 2005 to that in 2008?
Your response must be concise. 1.04. What is the ratio of the Income share held (as % of total income) in First 20% of population in 2005 to that in 2009?
Your answer should be very brief. 1.02. What is the ratio of the Income share held (as % of total income) in Second 20% of population in 2005 to that in 2009?
Your answer should be compact. 0.95. What is the ratio of the Income share held (as % of total income) in Third 20% of population in 2005 to that in 2009?
Make the answer very short. 0.99. What is the ratio of the Income share held (as % of total income) of Fourth 20% of population in 2005 to that in 2009?
Your answer should be very brief. 1.03. What is the ratio of the Income share held (as % of total income) of Second 20% of population in 2005 to that in 2010?
Provide a short and direct response. 0.99. What is the ratio of the Income share held (as % of total income) in Fourth 20% of population in 2005 to that in 2010?
Provide a succinct answer. 1. What is the ratio of the Income share held (as % of total income) in First 20% of population in 2006 to that in 2007?
Your response must be concise. 0.98. What is the ratio of the Income share held (as % of total income) of Second 20% of population in 2006 to that in 2007?
Offer a terse response. 1.02. What is the ratio of the Income share held (as % of total income) of Third 20% of population in 2006 to that in 2007?
Ensure brevity in your answer.  1.03. What is the ratio of the Income share held (as % of total income) in First 20% of population in 2006 to that in 2008?
Your answer should be compact. 0.99. What is the ratio of the Income share held (as % of total income) in Third 20% of population in 2006 to that in 2008?
Offer a terse response. 1.02. What is the ratio of the Income share held (as % of total income) in Fourth 20% of population in 2006 to that in 2008?
Provide a succinct answer. 1.03. What is the ratio of the Income share held (as % of total income) of First 20% of population in 2006 to that in 2009?
Make the answer very short. 1.02. What is the ratio of the Income share held (as % of total income) in Second 20% of population in 2006 to that in 2009?
Provide a short and direct response. 0.95. What is the ratio of the Income share held (as % of total income) of Fourth 20% of population in 2006 to that in 2009?
Offer a terse response. 1.02. What is the ratio of the Income share held (as % of total income) in First 20% of population in 2006 to that in 2010?
Make the answer very short. 1.01. What is the ratio of the Income share held (as % of total income) of Second 20% of population in 2006 to that in 2010?
Offer a very short reply. 0.99. What is the ratio of the Income share held (as % of total income) in Fourth 20% of population in 2006 to that in 2010?
Your answer should be compact. 0.99. What is the ratio of the Income share held (as % of total income) of Second 20% of population in 2007 to that in 2008?
Provide a short and direct response. 0.98. What is the ratio of the Income share held (as % of total income) in Third 20% of population in 2007 to that in 2008?
Your response must be concise. 0.99. What is the ratio of the Income share held (as % of total income) of Fourth 20% of population in 2007 to that in 2008?
Your answer should be very brief. 1.01. What is the ratio of the Income share held (as % of total income) of First 20% of population in 2007 to that in 2009?
Offer a terse response. 1.04. What is the ratio of the Income share held (as % of total income) of Second 20% of population in 2007 to that in 2009?
Offer a terse response. 0.93. What is the ratio of the Income share held (as % of total income) of Third 20% of population in 2007 to that in 2009?
Offer a very short reply. 0.96. What is the ratio of the Income share held (as % of total income) in First 20% of population in 2007 to that in 2010?
Your response must be concise. 1.03. What is the ratio of the Income share held (as % of total income) of Second 20% of population in 2007 to that in 2010?
Your answer should be very brief. 0.97. What is the ratio of the Income share held (as % of total income) in Third 20% of population in 2007 to that in 2010?
Keep it short and to the point. 0.97. What is the ratio of the Income share held (as % of total income) in Fourth 20% of population in 2007 to that in 2010?
Make the answer very short. 0.97. What is the ratio of the Income share held (as % of total income) in First 20% of population in 2008 to that in 2009?
Provide a short and direct response. 1.03. What is the ratio of the Income share held (as % of total income) in Second 20% of population in 2008 to that in 2009?
Your answer should be very brief. 0.96. What is the ratio of the Income share held (as % of total income) in Third 20% of population in 2008 to that in 2009?
Offer a terse response. 0.97. What is the ratio of the Income share held (as % of total income) in Fourth 20% of population in 2008 to that in 2009?
Ensure brevity in your answer.  0.99. What is the ratio of the Income share held (as % of total income) of First 20% of population in 2008 to that in 2010?
Provide a succinct answer. 1.02. What is the ratio of the Income share held (as % of total income) in Third 20% of population in 2008 to that in 2010?
Your response must be concise. 0.98. What is the ratio of the Income share held (as % of total income) of Fourth 20% of population in 2008 to that in 2010?
Give a very brief answer. 0.96. What is the ratio of the Income share held (as % of total income) in First 20% of population in 2009 to that in 2010?
Offer a very short reply. 0.99. What is the ratio of the Income share held (as % of total income) in Second 20% of population in 2009 to that in 2010?
Make the answer very short. 1.04. What is the ratio of the Income share held (as % of total income) of Third 20% of population in 2009 to that in 2010?
Give a very brief answer. 1.01. What is the ratio of the Income share held (as % of total income) of Fourth 20% of population in 2009 to that in 2010?
Your answer should be compact. 0.97. What is the difference between the highest and the second highest Income share held (as % of total income) of First 20% of population?
Offer a very short reply. 0.58. What is the difference between the highest and the lowest Income share held (as % of total income) in Second 20% of population?
Ensure brevity in your answer.  0.7. What is the difference between the highest and the lowest Income share held (as % of total income) of Third 20% of population?
Offer a very short reply. 0.57. What is the difference between the highest and the lowest Income share held (as % of total income) of Fourth 20% of population?
Provide a succinct answer. 1.11. 